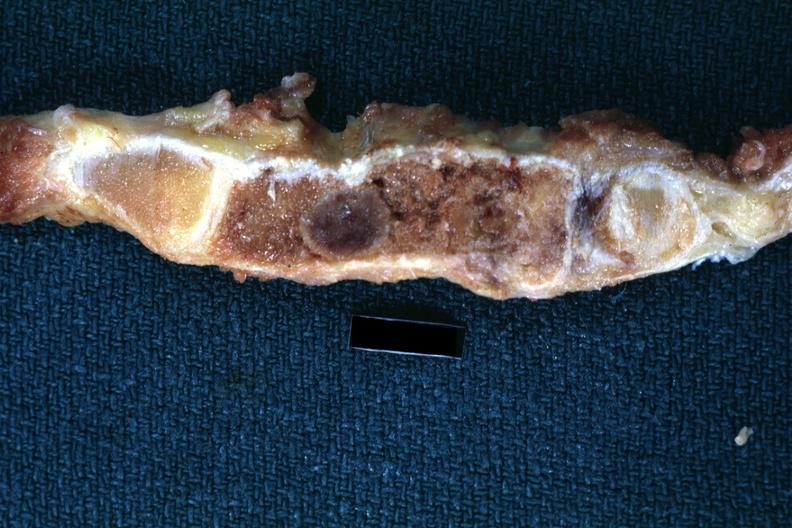how is section sternum with typical plasmacytoma shown close-up very?
Answer the question using a single word or phrase. Good 